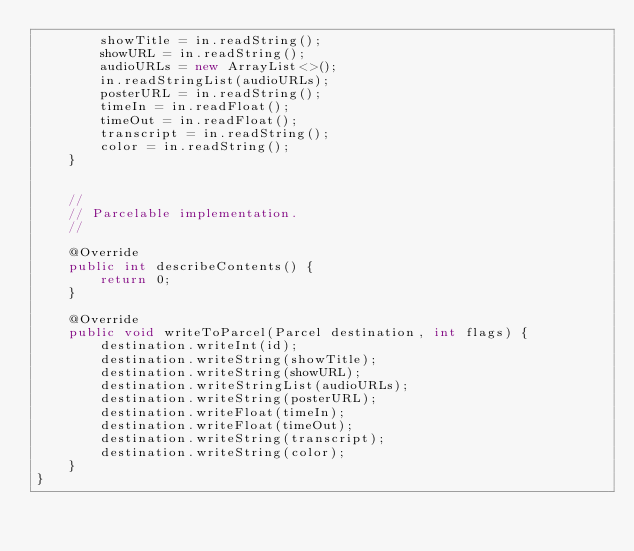<code> <loc_0><loc_0><loc_500><loc_500><_Java_>        showTitle = in.readString();
        showURL = in.readString();
        audioURLs = new ArrayList<>();
        in.readStringList(audioURLs);
        posterURL = in.readString();
        timeIn = in.readFloat();
        timeOut = in.readFloat();
        transcript = in.readString();
        color = in.readString();
    }


    //
    // Parcelable implementation.
    //

    @Override
    public int describeContents() {
        return 0;
    }

    @Override
    public void writeToParcel(Parcel destination, int flags) {
        destination.writeInt(id);
        destination.writeString(showTitle);
        destination.writeString(showURL);
        destination.writeStringList(audioURLs);
        destination.writeString(posterURL);
        destination.writeFloat(timeIn);
        destination.writeFloat(timeOut);
        destination.writeString(transcript);
        destination.writeString(color);
    }
}
</code> 